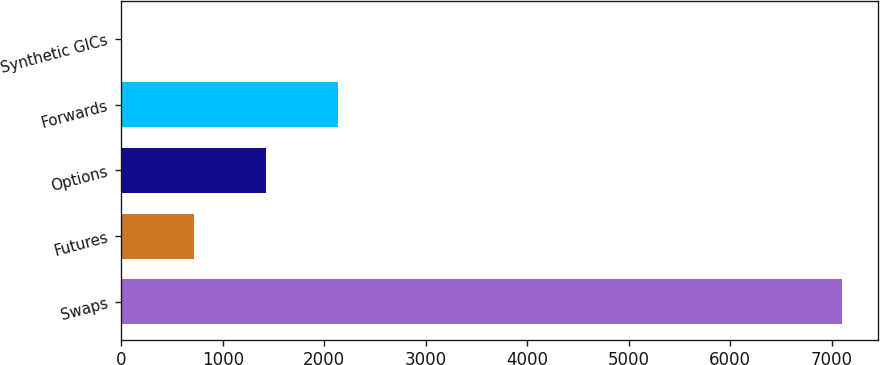Convert chart to OTSL. <chart><loc_0><loc_0><loc_500><loc_500><bar_chart><fcel>Swaps<fcel>Futures<fcel>Options<fcel>Forwards<fcel>Synthetic GICs<nl><fcel>7097<fcel>714.2<fcel>1423.4<fcel>2132.6<fcel>5<nl></chart> 